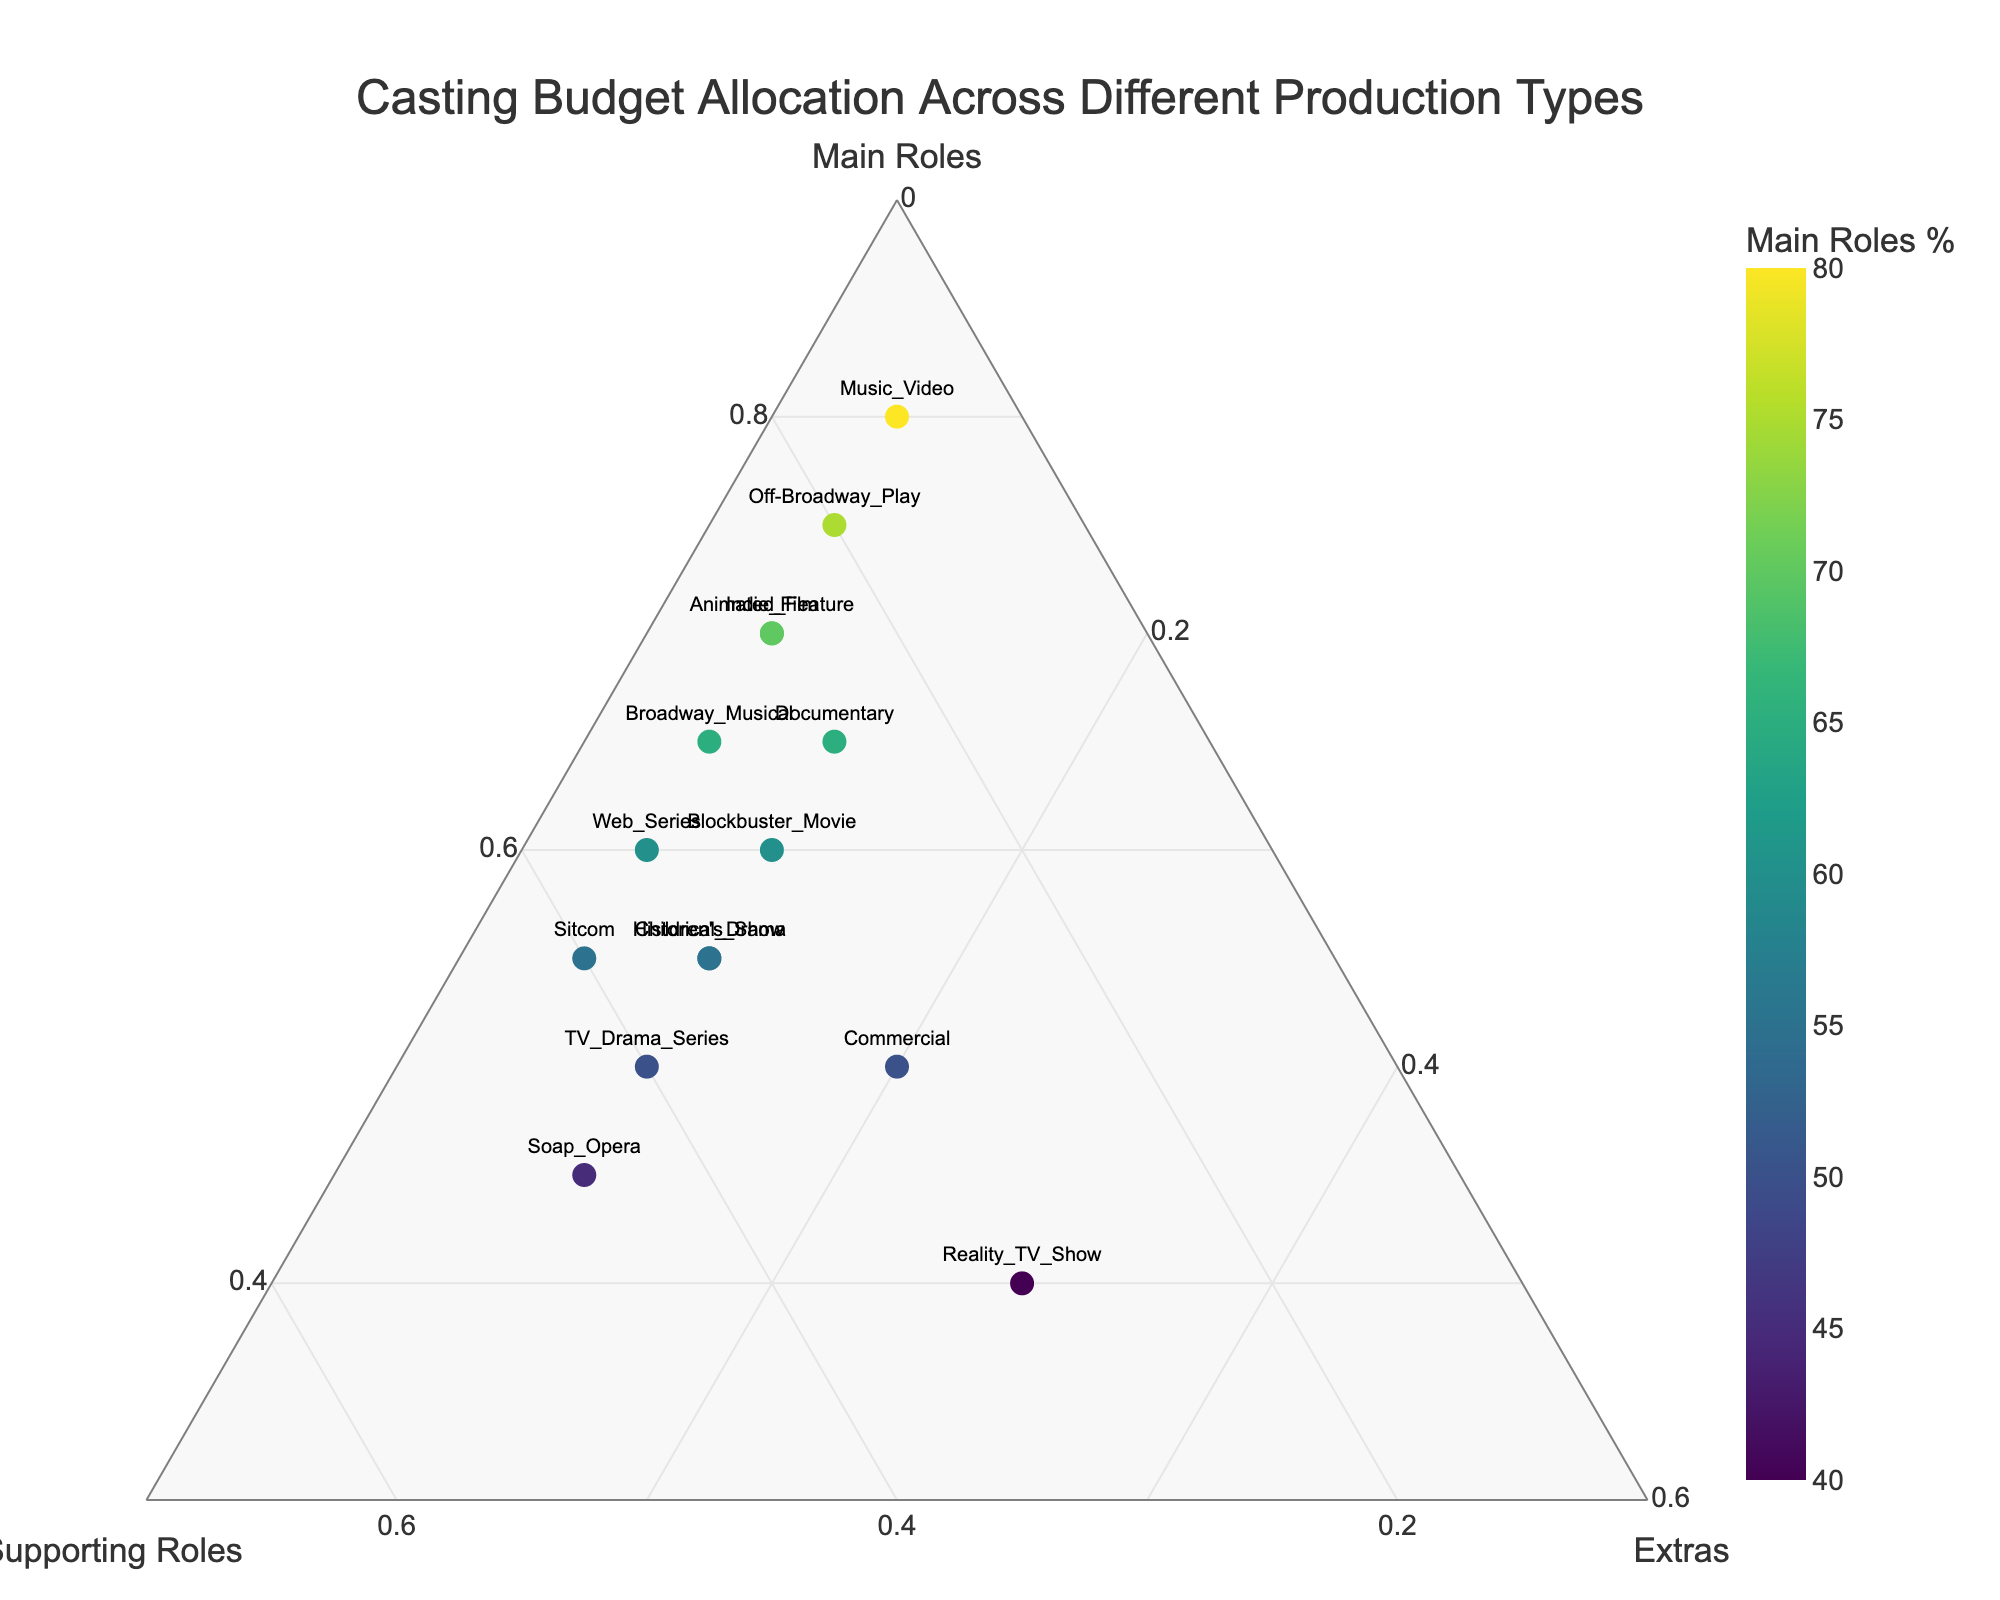What's the title of the figure? The title is displayed at the top of the figure, usually in larger, bold text. From the provided description, this title is about casting budget allocation across different types of productions.
Answer: Casting Budget Allocation Across Different Production Types How many production types are shown in the plot? Counting the unique points in the plot will give the number of production types. Each point represents a different production type based on the provided data description.
Answer: 15 Which production type allocates the highest percentage to main roles? Identify the point closest to the "Main Roles" corner of the ternary plot because higher values of main roles will be near this corner. Looking at the data, the Music Video production type allocates 80% to main roles.
Answer: Music Video What is the relationship between blockbuster movies and TV drama series in terms of supporting roles allocation? Compare their positions along the supporting roles axis. TV drama series allocate 40% to supporting roles while blockbuster movies allocate 30%.
Answer: TV Drama Series allocates more What's the percentage split for the Sitcom production type? Locate the Sitcom point on the ternary plot and read the percentages from the surrounding axes. From the data, Sitcom has 55% for main roles, 40% for supporting roles, and 5% for extras.
Answer: 55% main roles, 40% supporting roles, 5% extras Which types of productions have an equal percentage allocation to extras? Check the points along the "Extras" axis for any overlaps. From the data, both TV drama series and soap opera allocate 10% to extras.
Answer: TV Drama Series, Soap Opera Is there any production type that allocates 30% to extras? Looking at the trajectory of 30% on the extras axis and identifying the point on it will help us. The data shows Reality TV Show allocates 30% to extras.
Answer: Reality TV Show What is the average percentage of main roles across all production types? Sum up all the percentages of main roles and divide by the number of production types: (60+70+50+55+65+75+45+40+70+50+80+60+65+55+55)/15.
Answer: 60% Which production type is closest to having an equal allocation across main roles, supporting roles, and extras? Check the point closest to the center of the ternary plot, indicating a balance across all roles. None are perfectly balanced, but Soap Opera with 45% main roles, 45% supporting roles, and 10% extras is quite balanced.
Answer: Soap Opera Between animated feature and children's show, which allocates a higher percentage to supporting roles? Compare their locations with respect to the supporting roles axis. Animated Feature allocates 25% while Children's Show allocates 35%.
Answer: Children's Show 